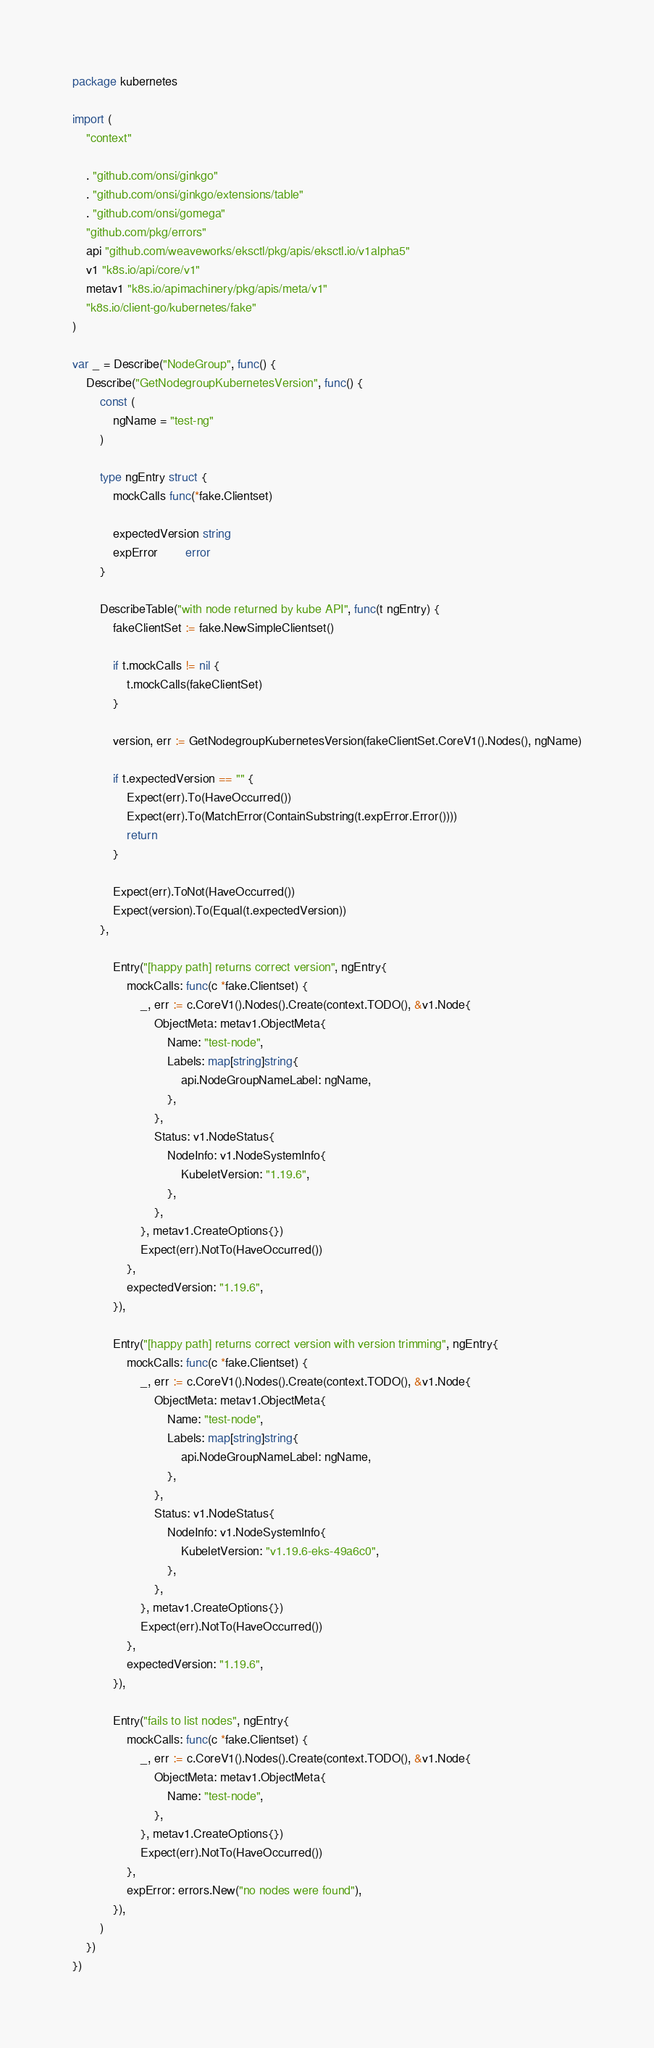Convert code to text. <code><loc_0><loc_0><loc_500><loc_500><_Go_>package kubernetes

import (
	"context"

	. "github.com/onsi/ginkgo"
	. "github.com/onsi/ginkgo/extensions/table"
	. "github.com/onsi/gomega"
	"github.com/pkg/errors"
	api "github.com/weaveworks/eksctl/pkg/apis/eksctl.io/v1alpha5"
	v1 "k8s.io/api/core/v1"
	metav1 "k8s.io/apimachinery/pkg/apis/meta/v1"
	"k8s.io/client-go/kubernetes/fake"
)

var _ = Describe("NodeGroup", func() {
	Describe("GetNodegroupKubernetesVersion", func() {
		const (
			ngName = "test-ng"
		)

		type ngEntry struct {
			mockCalls func(*fake.Clientset)

			expectedVersion string
			expError        error
		}

		DescribeTable("with node returned by kube API", func(t ngEntry) {
			fakeClientSet := fake.NewSimpleClientset()

			if t.mockCalls != nil {
				t.mockCalls(fakeClientSet)
			}

			version, err := GetNodegroupKubernetesVersion(fakeClientSet.CoreV1().Nodes(), ngName)

			if t.expectedVersion == "" {
				Expect(err).To(HaveOccurred())
				Expect(err).To(MatchError(ContainSubstring(t.expError.Error())))
				return
			}

			Expect(err).ToNot(HaveOccurred())
			Expect(version).To(Equal(t.expectedVersion))
		},

			Entry("[happy path] returns correct version", ngEntry{
				mockCalls: func(c *fake.Clientset) {
					_, err := c.CoreV1().Nodes().Create(context.TODO(), &v1.Node{
						ObjectMeta: metav1.ObjectMeta{
							Name: "test-node",
							Labels: map[string]string{
								api.NodeGroupNameLabel: ngName,
							},
						},
						Status: v1.NodeStatus{
							NodeInfo: v1.NodeSystemInfo{
								KubeletVersion: "1.19.6",
							},
						},
					}, metav1.CreateOptions{})
					Expect(err).NotTo(HaveOccurred())
				},
				expectedVersion: "1.19.6",
			}),

			Entry("[happy path] returns correct version with version trimming", ngEntry{
				mockCalls: func(c *fake.Clientset) {
					_, err := c.CoreV1().Nodes().Create(context.TODO(), &v1.Node{
						ObjectMeta: metav1.ObjectMeta{
							Name: "test-node",
							Labels: map[string]string{
								api.NodeGroupNameLabel: ngName,
							},
						},
						Status: v1.NodeStatus{
							NodeInfo: v1.NodeSystemInfo{
								KubeletVersion: "v1.19.6-eks-49a6c0",
							},
						},
					}, metav1.CreateOptions{})
					Expect(err).NotTo(HaveOccurred())
				},
				expectedVersion: "1.19.6",
			}),

			Entry("fails to list nodes", ngEntry{
				mockCalls: func(c *fake.Clientset) {
					_, err := c.CoreV1().Nodes().Create(context.TODO(), &v1.Node{
						ObjectMeta: metav1.ObjectMeta{
							Name: "test-node",
						},
					}, metav1.CreateOptions{})
					Expect(err).NotTo(HaveOccurred())
				},
				expError: errors.New("no nodes were found"),
			}),
		)
	})
})
</code> 